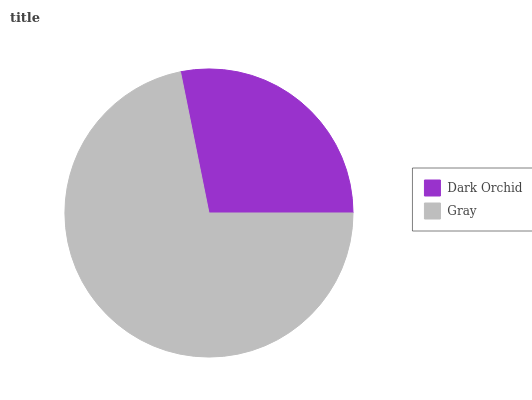Is Dark Orchid the minimum?
Answer yes or no. Yes. Is Gray the maximum?
Answer yes or no. Yes. Is Gray the minimum?
Answer yes or no. No. Is Gray greater than Dark Orchid?
Answer yes or no. Yes. Is Dark Orchid less than Gray?
Answer yes or no. Yes. Is Dark Orchid greater than Gray?
Answer yes or no. No. Is Gray less than Dark Orchid?
Answer yes or no. No. Is Gray the high median?
Answer yes or no. Yes. Is Dark Orchid the low median?
Answer yes or no. Yes. Is Dark Orchid the high median?
Answer yes or no. No. Is Gray the low median?
Answer yes or no. No. 